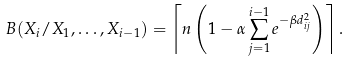<formula> <loc_0><loc_0><loc_500><loc_500>B ( X _ { i } / X _ { 1 } , \dots , X _ { i - 1 } ) = \left \lceil n \left ( 1 - \alpha \sum _ { j = 1 } ^ { i - 1 } e ^ { - \beta d _ { i j } ^ { 2 } } \right ) \right \rceil .</formula> 